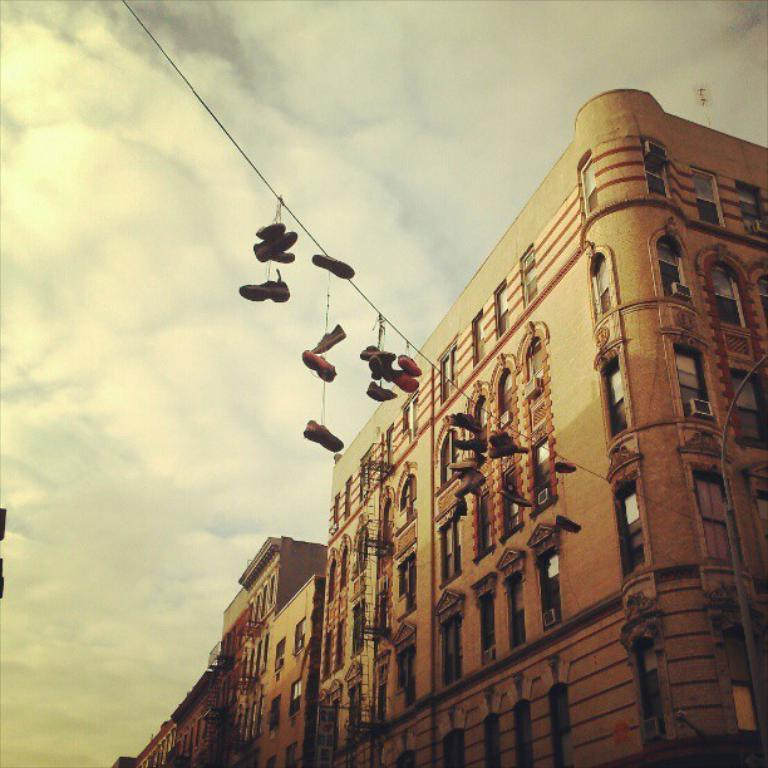What is the main structure in the image? There is a building in the middle of the image. Is there anything attached to the building? Yes, there is a rope attached to the building. What is hanging on the rope? Shoes are hanging on the rope. What can be seen at the top of the image? The sky is visible at the top of the image. Where are the dolls playing in the image? There are no dolls present in the image. What type of cup is being used to mine in the image? There is no mine or cup present in the image. 